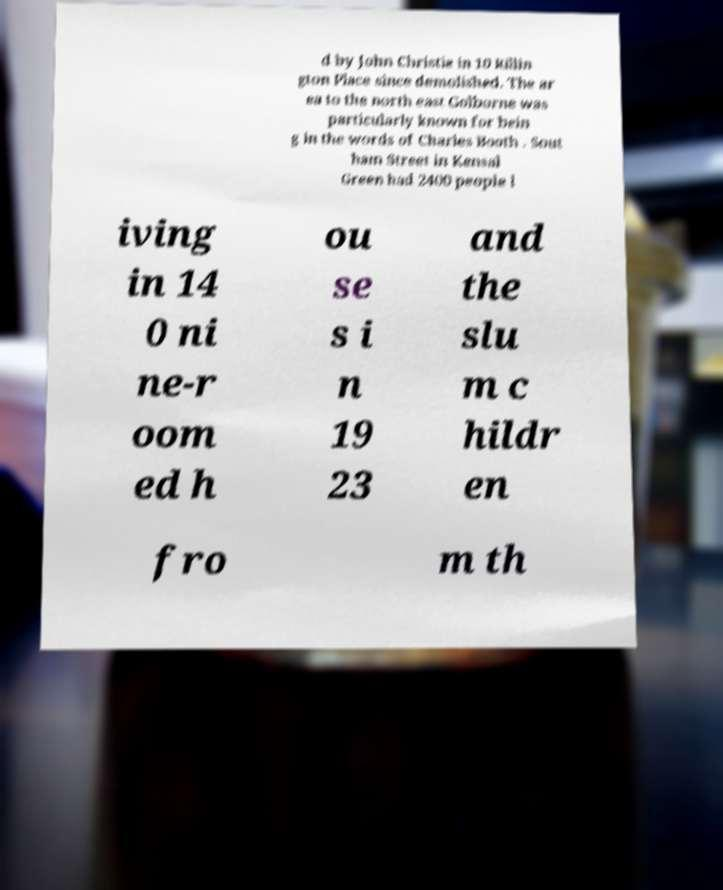Please read and relay the text visible in this image. What does it say? d by John Christie in 10 Rillin gton Place since demolished. The ar ea to the north east Golborne was particularly known for bein g in the words of Charles Booth . Sout ham Street in Kensal Green had 2400 people l iving in 14 0 ni ne-r oom ed h ou se s i n 19 23 and the slu m c hildr en fro m th 